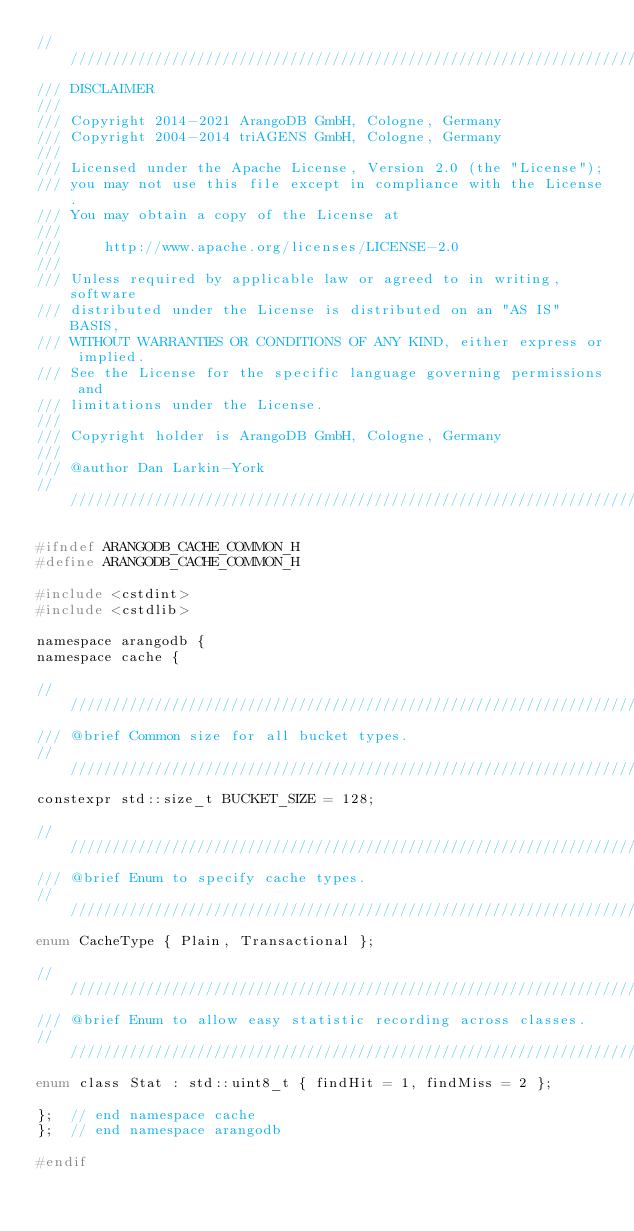<code> <loc_0><loc_0><loc_500><loc_500><_C_>////////////////////////////////////////////////////////////////////////////////
/// DISCLAIMER
///
/// Copyright 2014-2021 ArangoDB GmbH, Cologne, Germany
/// Copyright 2004-2014 triAGENS GmbH, Cologne, Germany
///
/// Licensed under the Apache License, Version 2.0 (the "License");
/// you may not use this file except in compliance with the License.
/// You may obtain a copy of the License at
///
///     http://www.apache.org/licenses/LICENSE-2.0
///
/// Unless required by applicable law or agreed to in writing, software
/// distributed under the License is distributed on an "AS IS" BASIS,
/// WITHOUT WARRANTIES OR CONDITIONS OF ANY KIND, either express or implied.
/// See the License for the specific language governing permissions and
/// limitations under the License.
///
/// Copyright holder is ArangoDB GmbH, Cologne, Germany
///
/// @author Dan Larkin-York
////////////////////////////////////////////////////////////////////////////////

#ifndef ARANGODB_CACHE_COMMON_H
#define ARANGODB_CACHE_COMMON_H

#include <cstdint>
#include <cstdlib>

namespace arangodb {
namespace cache {

////////////////////////////////////////////////////////////////////////////////
/// @brief Common size for all bucket types.
////////////////////////////////////////////////////////////////////////////////
constexpr std::size_t BUCKET_SIZE = 128;

////////////////////////////////////////////////////////////////////////////////
/// @brief Enum to specify cache types.
////////////////////////////////////////////////////////////////////////////////
enum CacheType { Plain, Transactional };

////////////////////////////////////////////////////////////////////////////////
/// @brief Enum to allow easy statistic recording across classes.
////////////////////////////////////////////////////////////////////////////////
enum class Stat : std::uint8_t { findHit = 1, findMiss = 2 };

};  // end namespace cache
};  // end namespace arangodb

#endif
</code> 